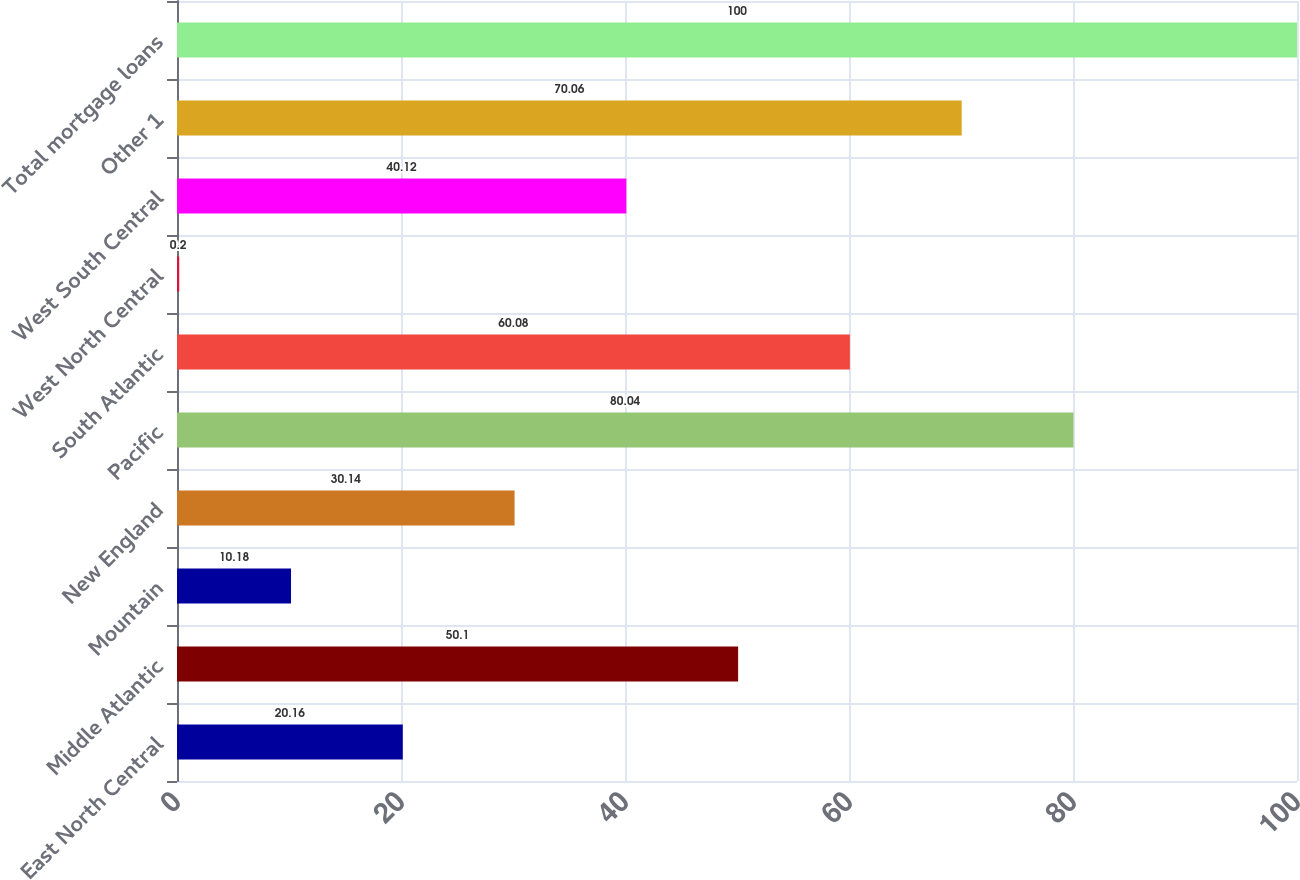Convert chart to OTSL. <chart><loc_0><loc_0><loc_500><loc_500><bar_chart><fcel>East North Central<fcel>Middle Atlantic<fcel>Mountain<fcel>New England<fcel>Pacific<fcel>South Atlantic<fcel>West North Central<fcel>West South Central<fcel>Other 1<fcel>Total mortgage loans<nl><fcel>20.16<fcel>50.1<fcel>10.18<fcel>30.14<fcel>80.04<fcel>60.08<fcel>0.2<fcel>40.12<fcel>70.06<fcel>100<nl></chart> 